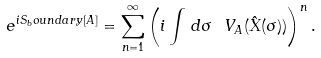<formula> <loc_0><loc_0><loc_500><loc_500>e ^ { i S _ { b } o u n d a r y [ A ] } = \sum _ { n = 1 } ^ { \infty } \left ( i \int \, d \sigma \ V _ { A } ( \hat { X } ( \sigma ) ) \right ) ^ { n } .</formula> 